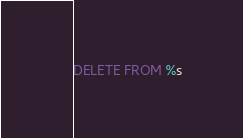<code> <loc_0><loc_0><loc_500><loc_500><_SQL_>DELETE FROM %s</code> 